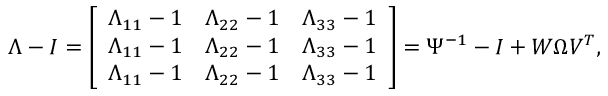Convert formula to latex. <formula><loc_0><loc_0><loc_500><loc_500>\begin{array} { r l } & { \Lambda - I = \left [ \begin{array} { l l l } { \Lambda _ { 1 1 } - 1 } & { \Lambda _ { 2 2 } - 1 } & { \Lambda _ { 3 3 } - 1 } \\ { \Lambda _ { 1 1 } - 1 } & { \Lambda _ { 2 2 } - 1 } & { \Lambda _ { 3 3 } - 1 } \\ { \Lambda _ { 1 1 } - 1 } & { \Lambda _ { 2 2 } - 1 } & { \Lambda _ { 3 3 } - 1 } \end{array} \right ] = \Psi ^ { - 1 } - I + W \Omega V ^ { T } , } \end{array}</formula> 